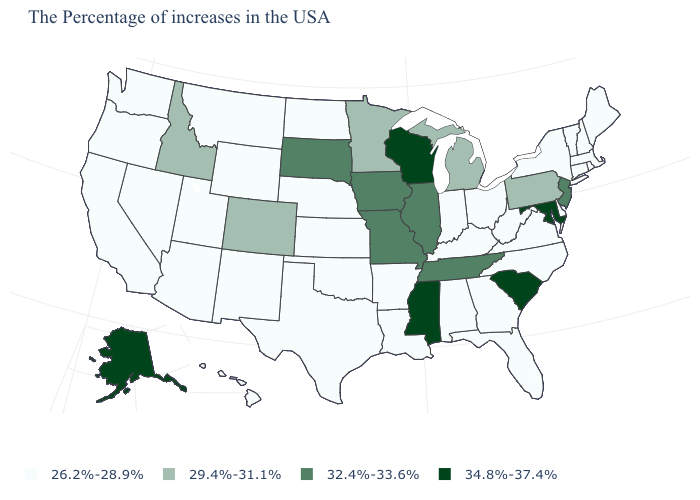Which states have the lowest value in the USA?
Short answer required. Maine, Massachusetts, Rhode Island, New Hampshire, Vermont, Connecticut, New York, Delaware, Virginia, North Carolina, West Virginia, Ohio, Florida, Georgia, Kentucky, Indiana, Alabama, Louisiana, Arkansas, Kansas, Nebraska, Oklahoma, Texas, North Dakota, Wyoming, New Mexico, Utah, Montana, Arizona, Nevada, California, Washington, Oregon, Hawaii. What is the value of Maryland?
Answer briefly. 34.8%-37.4%. Does New York have the same value as New Jersey?
Write a very short answer. No. How many symbols are there in the legend?
Concise answer only. 4. Name the states that have a value in the range 32.4%-33.6%?
Write a very short answer. New Jersey, Tennessee, Illinois, Missouri, Iowa, South Dakota. Name the states that have a value in the range 34.8%-37.4%?
Be succinct. Maryland, South Carolina, Wisconsin, Mississippi, Alaska. Among the states that border Nebraska , does Kansas have the lowest value?
Be succinct. Yes. What is the value of Alaska?
Write a very short answer. 34.8%-37.4%. What is the value of Connecticut?
Answer briefly. 26.2%-28.9%. What is the value of Minnesota?
Give a very brief answer. 29.4%-31.1%. Among the states that border Missouri , does Oklahoma have the highest value?
Give a very brief answer. No. What is the value of West Virginia?
Short answer required. 26.2%-28.9%. Among the states that border Mississippi , does Tennessee have the highest value?
Quick response, please. Yes. Does Arizona have the highest value in the USA?
Short answer required. No. What is the value of South Carolina?
Give a very brief answer. 34.8%-37.4%. 